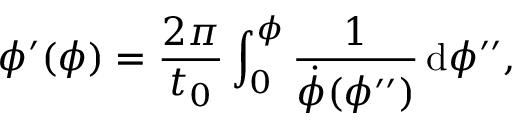<formula> <loc_0><loc_0><loc_500><loc_500>\phi ^ { \prime } ( \phi ) = \frac { 2 \pi } { t _ { 0 } } \int _ { 0 } ^ { \phi } \frac { 1 } { \dot { \phi } ( \phi ^ { \prime \prime } ) } \, d \phi ^ { \prime \prime } ,</formula> 